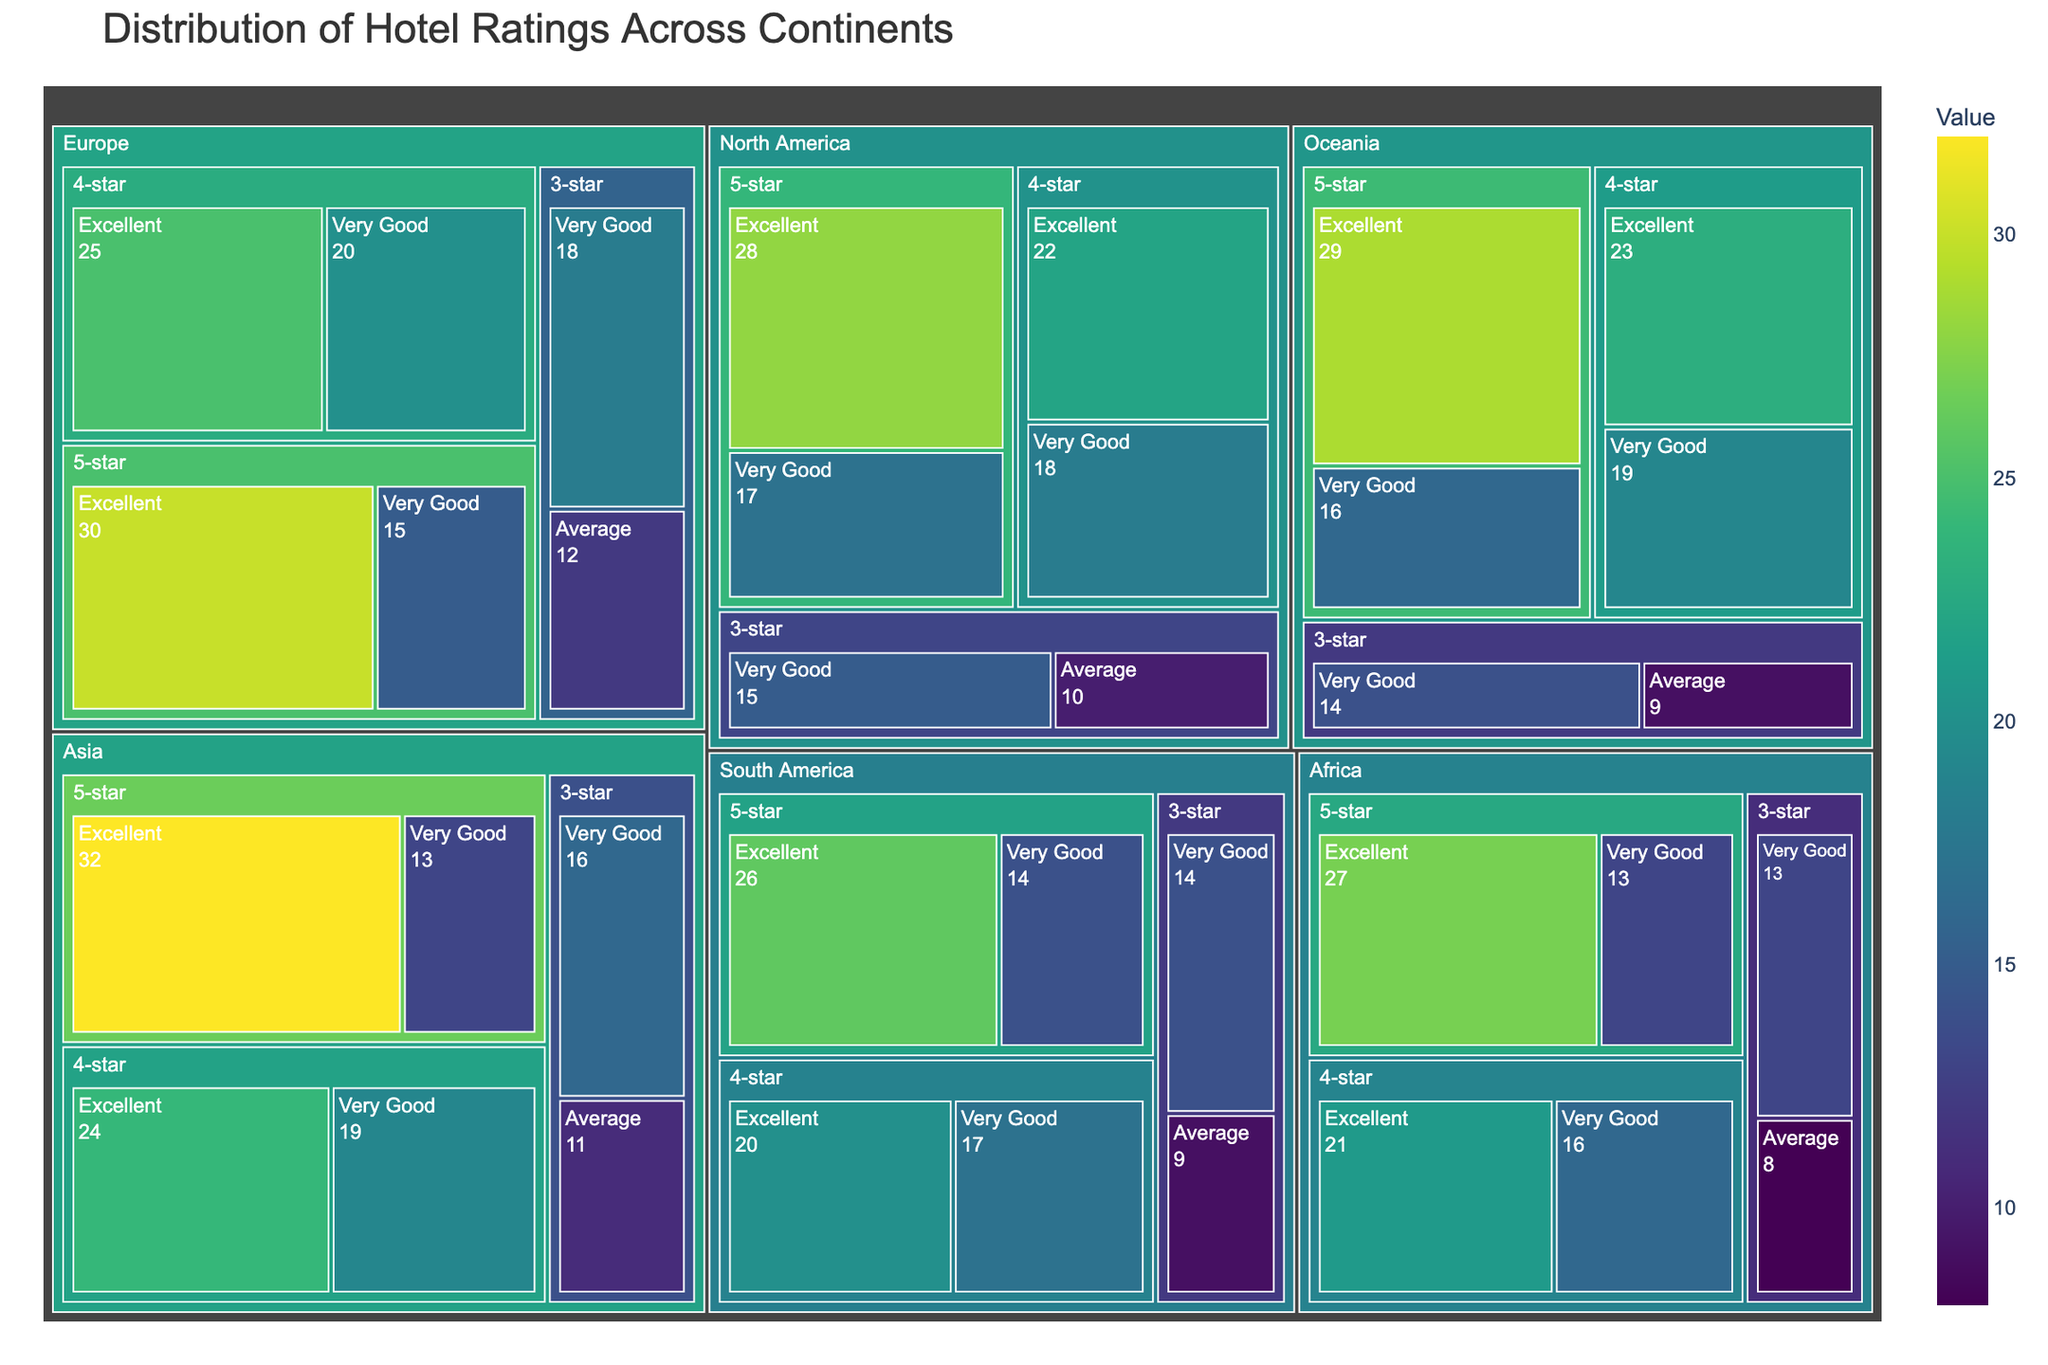What is the title of the figure? The title can be found at the top of the figure and provides a summary of what the figure represents.
Answer: Distribution of Hotel Ratings Across Continents Which continent has the highest number of 5-star "Excellent" ratings? By looking at each continent's section and identifying the star category and corresponding "Excellent" rating, we can see and compare the values. Asia has the highest such rating with a value of 32.
Answer: Asia What is the total number of "Very Good" ratings for Europe? Sum the values of all "Very Good" ratings across different star categories for Europe: 5-star (15) + 4-star (20) + 3-star (18) = 53.
Answer: 53 How does the number of 4-star "Excellent" ratings in North America compare to those in Europe? Compare the values of 4-star "Excellent" ratings for each continent: North America has 22, and Europe has 25. Europe has a higher number.
Answer: Europe has a higher number What is the difference between the number of 3-star "Average" ratings in South America and Africa? Find and subtract the value for South America from Africa: South America (9) - Africa (8) = 1.
Answer: 1 Which continent has the least number of 4-star "Very Good" ratings? Compare the values for 4-star "Very Good" ratings across all continents: Africa has the least with a value of 16.
Answer: Africa What is the combined total of 5-star ratings (both "Excellent" and "Very Good") for Oceania? Add the values for both "Excellent" and "Very Good" in the 5-star category: 5-star "Excellent" (29) + 5-star "Very Good" (16) = 45.
Answer: 45 Which continent has more 3-star "Very Good" ratings, North America or South America? Compare the 3-star "Very Good" ratings between the two continents: North America (15) vs. South America (14). North America has more.
Answer: North America How does the number of 5-star "Very Good" ratings in Africa compare to those in Asia? Compare the values for both: Africa has 13, and Asia has 13. They have the same number.
Answer: They are equal What is the largest value displayed for any category in Europe? Examine all the values within Europe's section and identify the highest one: The highest value is 30 for 5-star "Excellent."
Answer: 30 